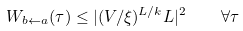Convert formula to latex. <formula><loc_0><loc_0><loc_500><loc_500>W _ { b \leftarrow a } ( \tau ) \leq | ( V / \xi ) ^ { L / k } L | ^ { 2 } \quad \forall \tau</formula> 